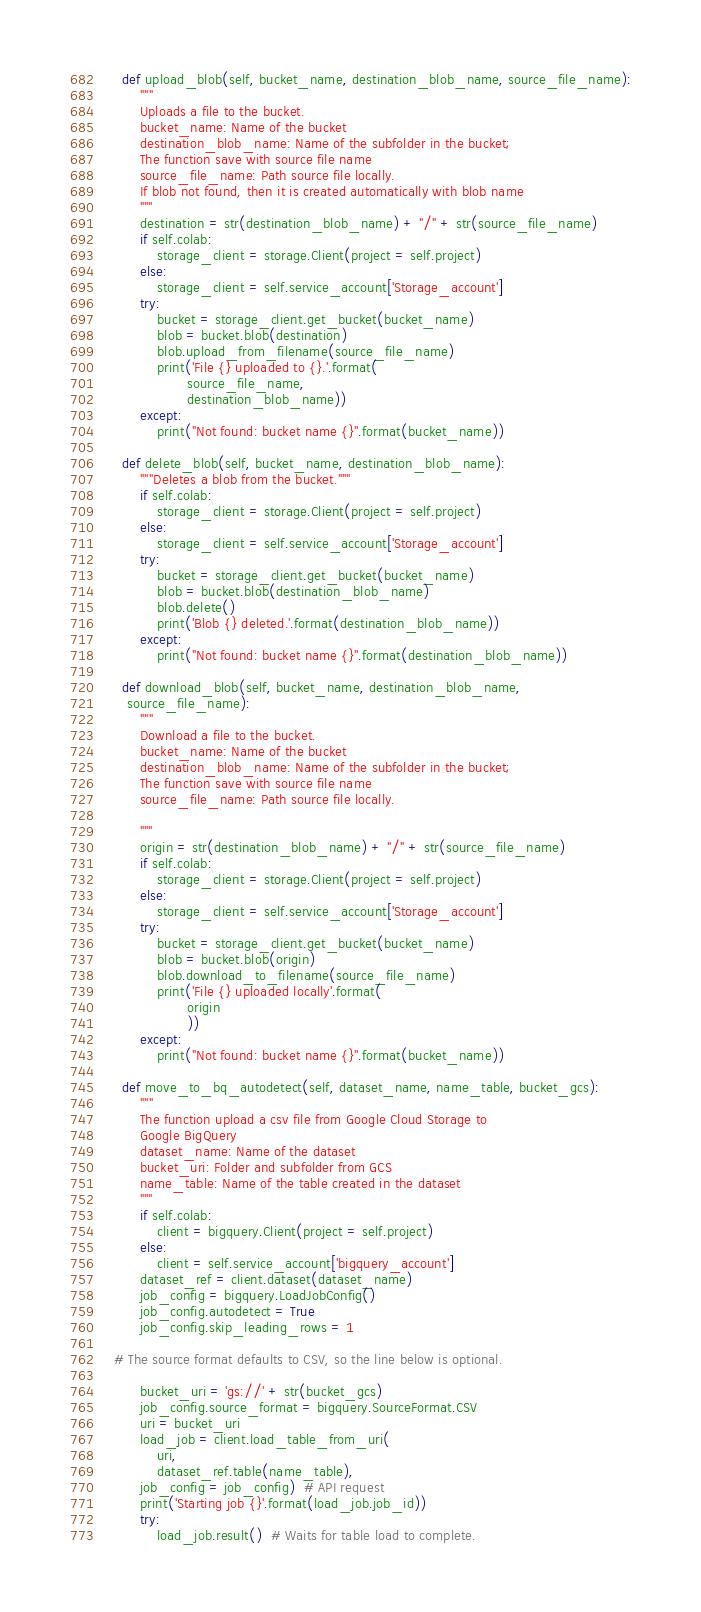Convert code to text. <code><loc_0><loc_0><loc_500><loc_500><_Python_>
	def upload_blob(self, bucket_name, destination_blob_name, source_file_name):
		"""
		Uploads a file to the bucket.
		bucket_name: Name of the bucket
		destination_blob_name: Name of the subfolder in the bucket;
		The function save with source file name
		source_file_name: Path source file locally.
		If blob not found, then it is created automatically with blob name
		"""
		destination = str(destination_blob_name) + "/" + str(source_file_name)
		if self.colab:
			storage_client = storage.Client(project = self.project)
		else:
			storage_client = self.service_account['Storage_account']
		try:
			bucket = storage_client.get_bucket(bucket_name)
			blob = bucket.blob(destination)
			blob.upload_from_filename(source_file_name)
			print('File {} uploaded to {}.'.format(
				   source_file_name,
				   destination_blob_name))
		except:
			print("Not found: bucket name {}".format(bucket_name))

	def delete_blob(self, bucket_name, destination_blob_name):
		"""Deletes a blob from the bucket."""
		if self.colab:
			storage_client = storage.Client(project = self.project)
		else:
			storage_client = self.service_account['Storage_account']
		try:
			bucket = storage_client.get_bucket(bucket_name)
			blob = bucket.blob(destination_blob_name)
			blob.delete()
			print('Blob {} deleted.'.format(destination_blob_name))
		except:
			print("Not found: bucket name {}".format(destination_blob_name))

	def download_blob(self, bucket_name, destination_blob_name,
	 source_file_name):
		"""
		Download a file to the bucket.
		bucket_name: Name of the bucket
		destination_blob_name: Name of the subfolder in the bucket;
		The function save with source file name
		source_file_name: Path source file locally.

		"""
		origin = str(destination_blob_name) + "/" + str(source_file_name)
		if self.colab:
			storage_client = storage.Client(project = self.project)
		else:
			storage_client = self.service_account['Storage_account']
		try:
			bucket = storage_client.get_bucket(bucket_name)
			blob = bucket.blob(origin)
			blob.download_to_filename(source_file_name)
			print('File {} uploaded locally'.format(
				   origin
				   ))
		except:
			print("Not found: bucket name {}".format(bucket_name))

	def move_to_bq_autodetect(self, dataset_name, name_table, bucket_gcs):
		"""
		The function upload a csv file from Google Cloud Storage to
		Google BigQuery
		dataset_name: Name of the dataset
		bucket_uri: Folder and subfolder from GCS
		name_table: Name of the table created in the dataset
		"""
		if self.colab:
			client = bigquery.Client(project = self.project)
		else:
			client = self.service_account['bigquery_account']
		dataset_ref = client.dataset(dataset_name)
		job_config = bigquery.LoadJobConfig()
		job_config.autodetect = True
		job_config.skip_leading_rows = 1

  # The source format defaults to CSV, so the line below is optional.

		bucket_uri = 'gs://' + str(bucket_gcs)
		job_config.source_format = bigquery.SourceFormat.CSV
		uri = bucket_uri
		load_job = client.load_table_from_uri(
			uri,
			dataset_ref.table(name_table),
		job_config = job_config)  # API request
		print('Starting job {}'.format(load_job.job_id))
		try:
			load_job.result()  # Waits for table load to complete.</code> 